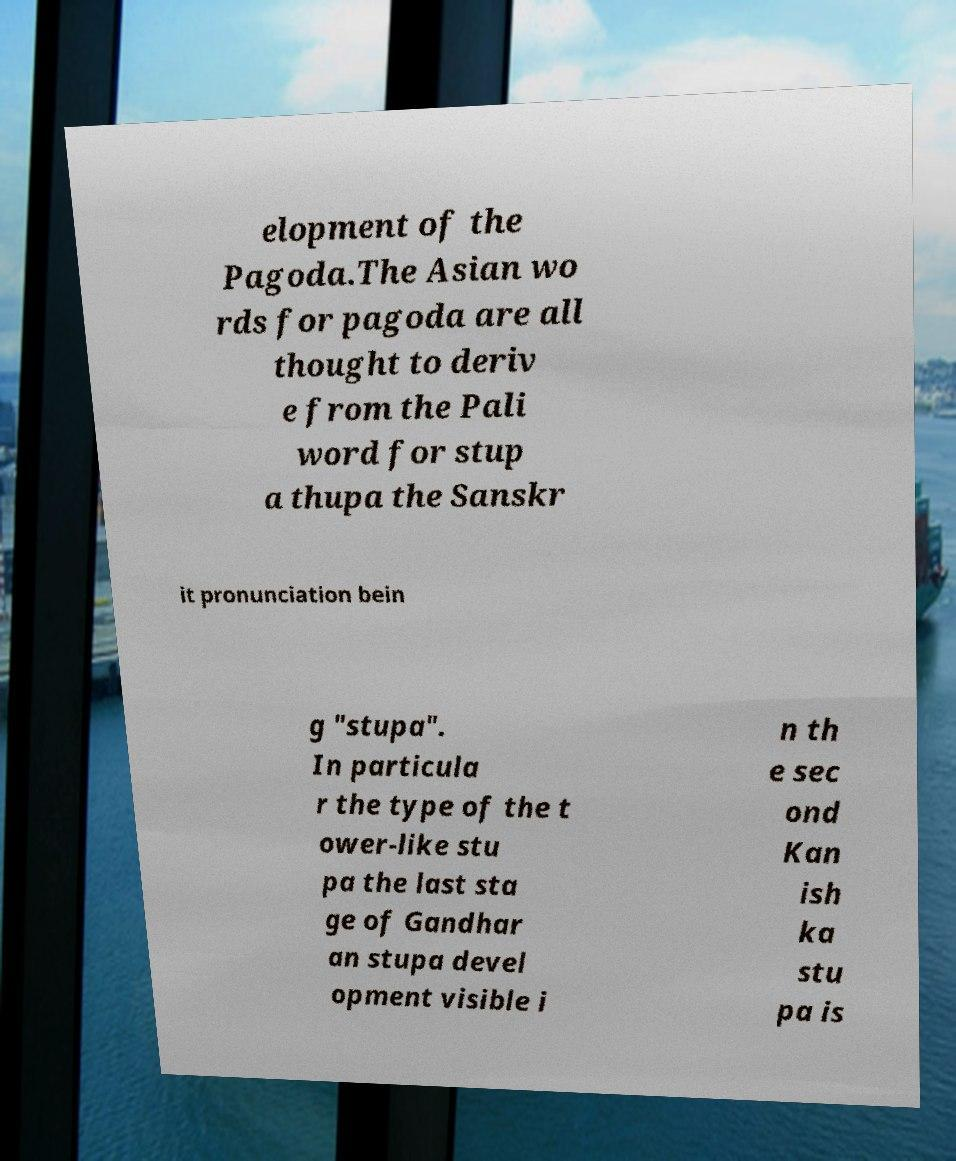Could you extract and type out the text from this image? elopment of the Pagoda.The Asian wo rds for pagoda are all thought to deriv e from the Pali word for stup a thupa the Sanskr it pronunciation bein g "stupa". In particula r the type of the t ower-like stu pa the last sta ge of Gandhar an stupa devel opment visible i n th e sec ond Kan ish ka stu pa is 